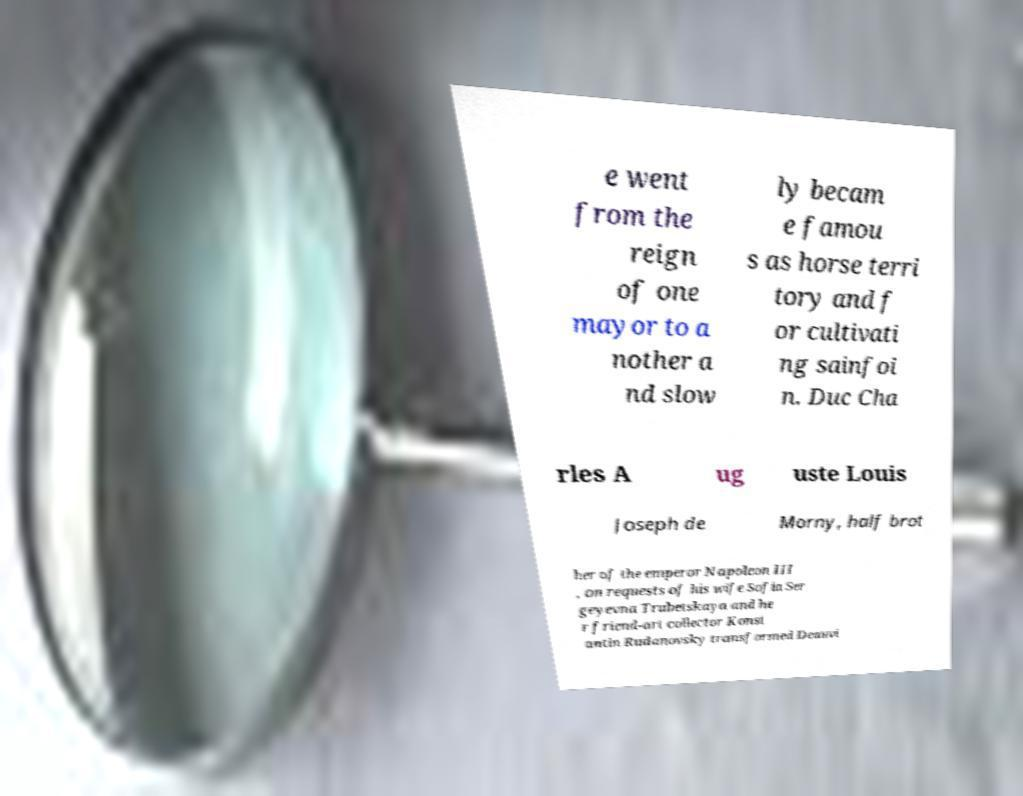There's text embedded in this image that I need extracted. Can you transcribe it verbatim? e went from the reign of one mayor to a nother a nd slow ly becam e famou s as horse terri tory and f or cultivati ng sainfoi n. Duc Cha rles A ug uste Louis Joseph de Morny, half brot her of the emperor Napoleon III , on requests of his wife Sofia Ser geyevna Trubetskaya and he r friend-art collector Konst antin Rudanovsky transformed Deauvi 